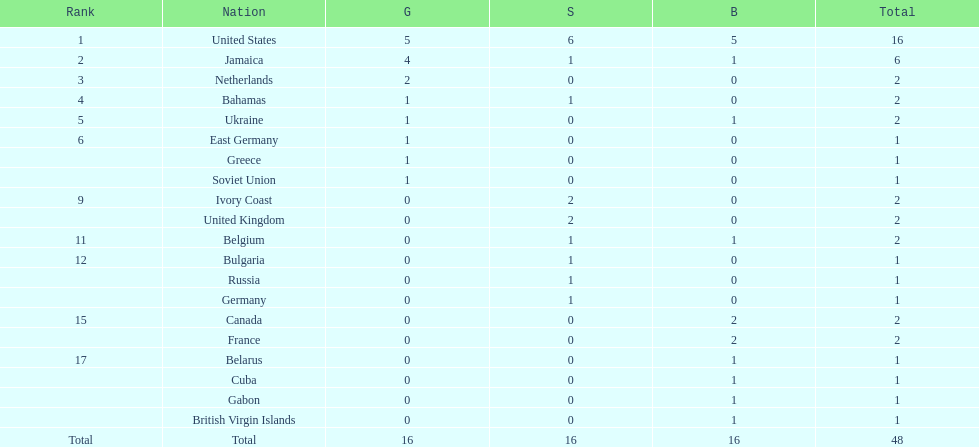What country won the most silver medals? United States. 